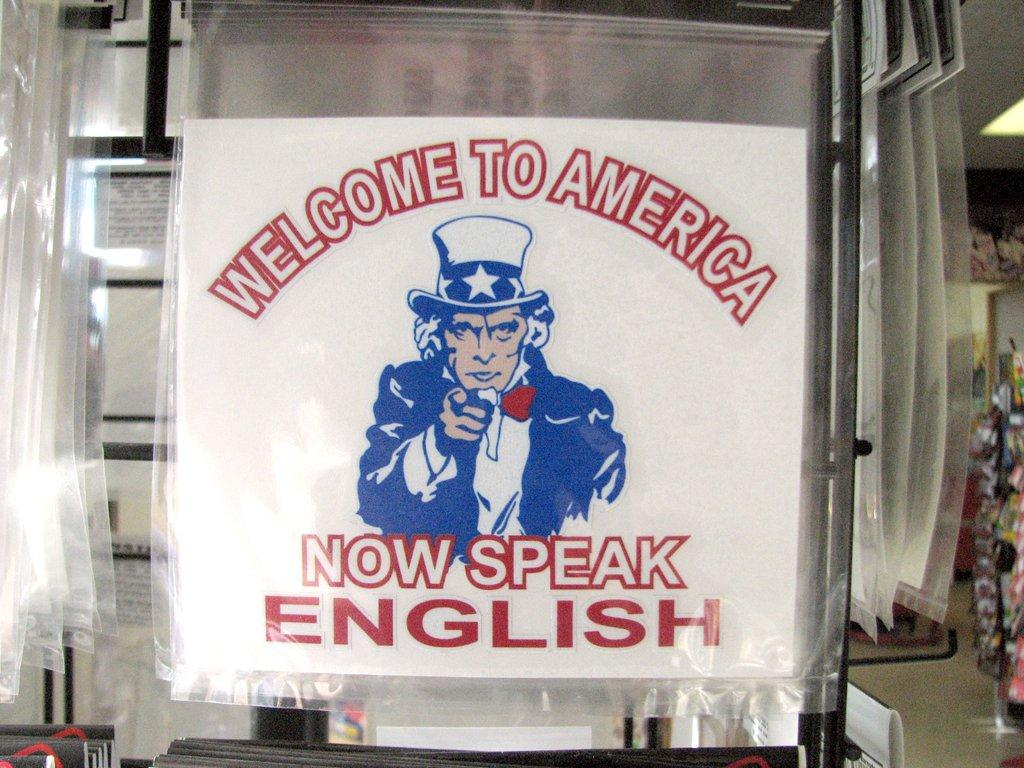<image>
Present a compact description of the photo's key features. An image of Uncle Sam telling people to speak English. 